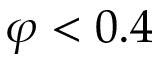<formula> <loc_0><loc_0><loc_500><loc_500>\varphi < 0 . 4</formula> 